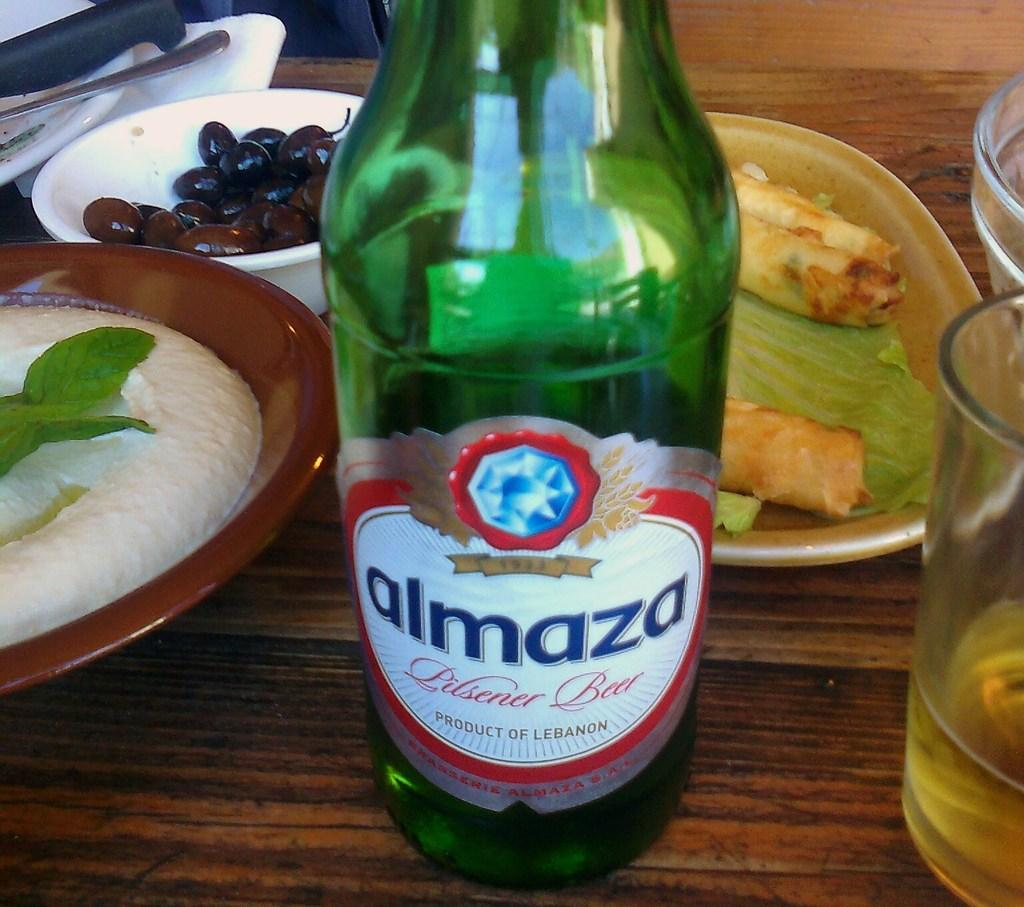<image>
Present a compact description of the photo's key features. A green bottle of Almaza beer sits on a table. 